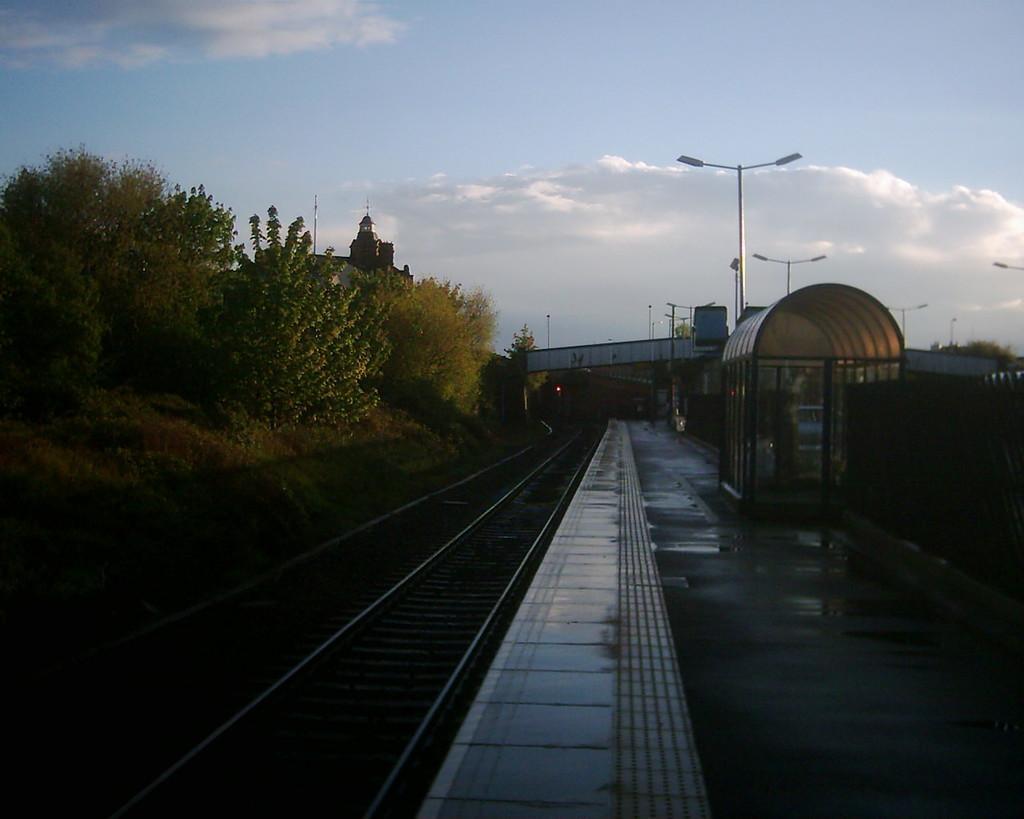Describe this image in one or two sentences. In this image, there are a few plants, trees, poles. We can see the railway tracks. We can see the ground with some objects. We can also see the bridge and the sky with clouds. 